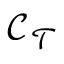Convert formula to latex. <formula><loc_0><loc_0><loc_500><loc_500>\mathcal { C } _ { \mathcal { T } }</formula> 